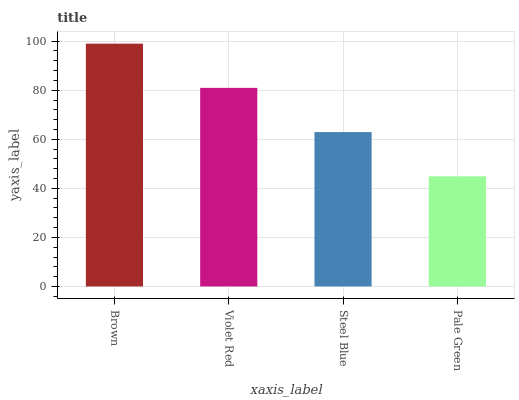Is Violet Red the minimum?
Answer yes or no. No. Is Violet Red the maximum?
Answer yes or no. No. Is Brown greater than Violet Red?
Answer yes or no. Yes. Is Violet Red less than Brown?
Answer yes or no. Yes. Is Violet Red greater than Brown?
Answer yes or no. No. Is Brown less than Violet Red?
Answer yes or no. No. Is Violet Red the high median?
Answer yes or no. Yes. Is Steel Blue the low median?
Answer yes or no. Yes. Is Brown the high median?
Answer yes or no. No. Is Brown the low median?
Answer yes or no. No. 